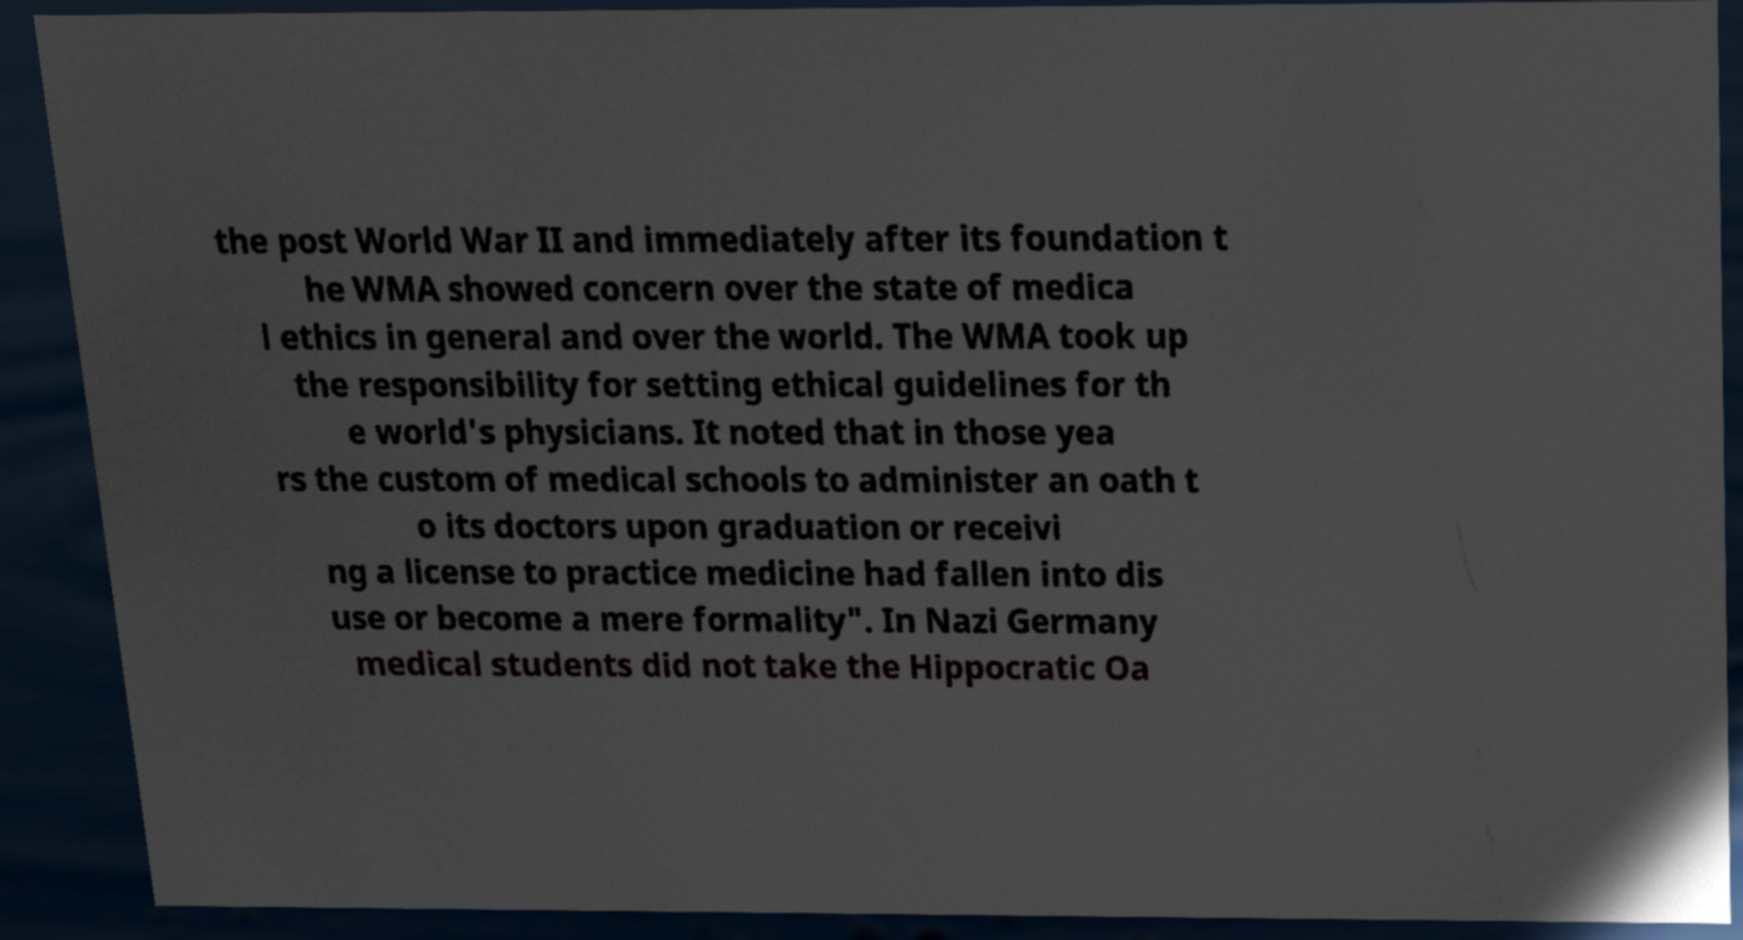Please identify and transcribe the text found in this image. the post World War II and immediately after its foundation t he WMA showed concern over the state of medica l ethics in general and over the world. The WMA took up the responsibility for setting ethical guidelines for th e world's physicians. It noted that in those yea rs the custom of medical schools to administer an oath t o its doctors upon graduation or receivi ng a license to practice medicine had fallen into dis use or become a mere formality". In Nazi Germany medical students did not take the Hippocratic Oa 